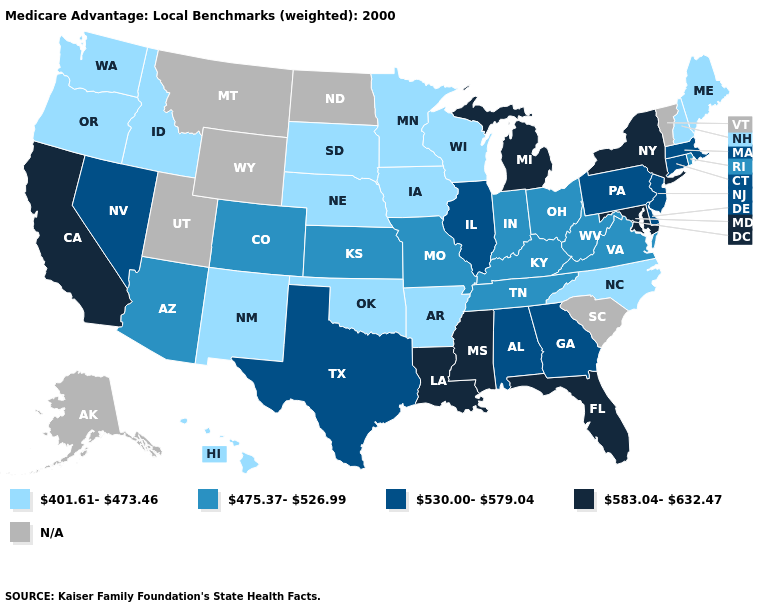What is the value of Tennessee?
Write a very short answer. 475.37-526.99. What is the value of North Dakota?
Short answer required. N/A. Does Idaho have the lowest value in the USA?
Write a very short answer. Yes. Which states have the highest value in the USA?
Write a very short answer. California, Florida, Louisiana, Maryland, Michigan, Mississippi, New York. What is the value of Missouri?
Concise answer only. 475.37-526.99. Which states have the lowest value in the USA?
Keep it brief. Arkansas, Hawaii, Iowa, Idaho, Maine, Minnesota, North Carolina, Nebraska, New Hampshire, New Mexico, Oklahoma, Oregon, South Dakota, Washington, Wisconsin. Among the states that border Idaho , does Nevada have the highest value?
Write a very short answer. Yes. What is the highest value in the Northeast ?
Keep it brief. 583.04-632.47. Among the states that border Pennsylvania , which have the lowest value?
Give a very brief answer. Ohio, West Virginia. What is the value of Alaska?
Give a very brief answer. N/A. Does the map have missing data?
Quick response, please. Yes. Among the states that border Illinois , which have the lowest value?
Answer briefly. Iowa, Wisconsin. 